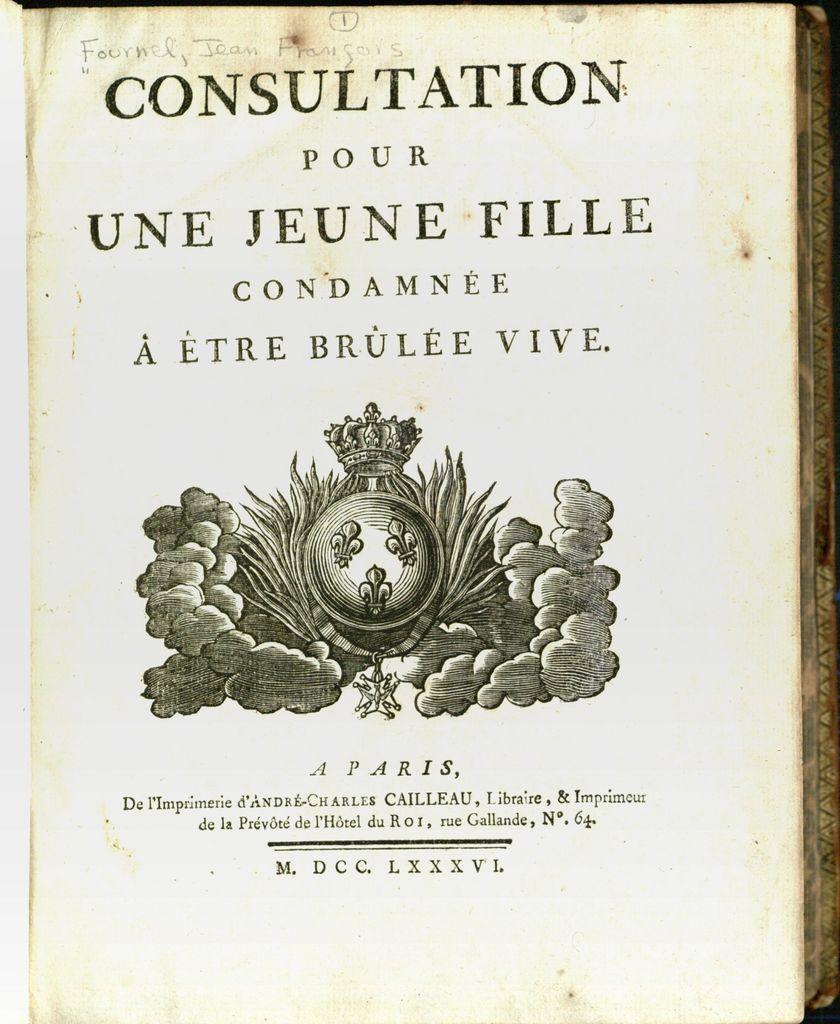What is the book title?
Make the answer very short. Consultation pour une jeune fille condamnee a etre brulee vive. 